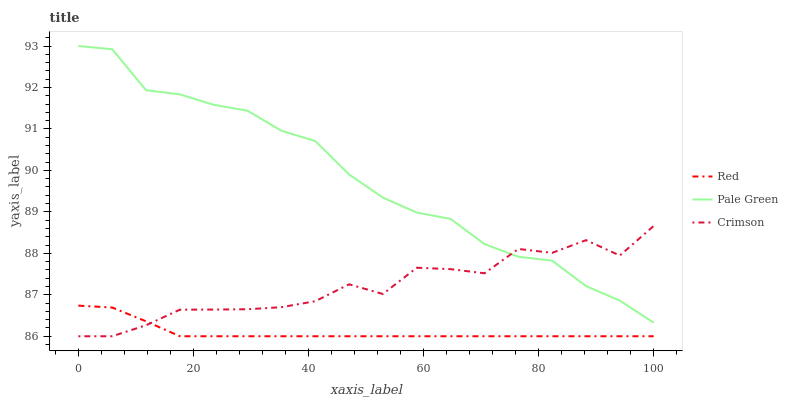Does Red have the minimum area under the curve?
Answer yes or no. Yes. Does Pale Green have the maximum area under the curve?
Answer yes or no. Yes. Does Pale Green have the minimum area under the curve?
Answer yes or no. No. Does Red have the maximum area under the curve?
Answer yes or no. No. Is Red the smoothest?
Answer yes or no. Yes. Is Crimson the roughest?
Answer yes or no. Yes. Is Pale Green the smoothest?
Answer yes or no. No. Is Pale Green the roughest?
Answer yes or no. No. Does Crimson have the lowest value?
Answer yes or no. Yes. Does Pale Green have the lowest value?
Answer yes or no. No. Does Pale Green have the highest value?
Answer yes or no. Yes. Does Red have the highest value?
Answer yes or no. No. Is Red less than Pale Green?
Answer yes or no. Yes. Is Pale Green greater than Red?
Answer yes or no. Yes. Does Crimson intersect Red?
Answer yes or no. Yes. Is Crimson less than Red?
Answer yes or no. No. Is Crimson greater than Red?
Answer yes or no. No. Does Red intersect Pale Green?
Answer yes or no. No. 